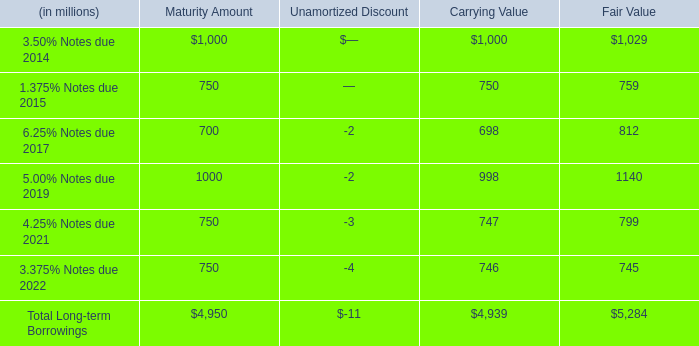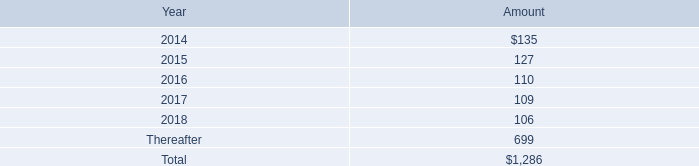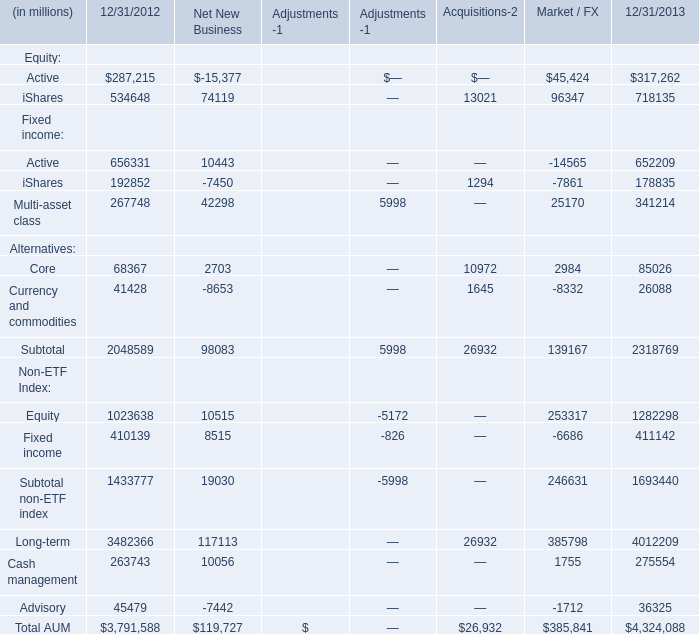What was the average value of the iShares in the years where iShares is positive? (in million) 
Computations: (((192852 + 1294) + 178835) / 3)
Answer: 124327.0. 